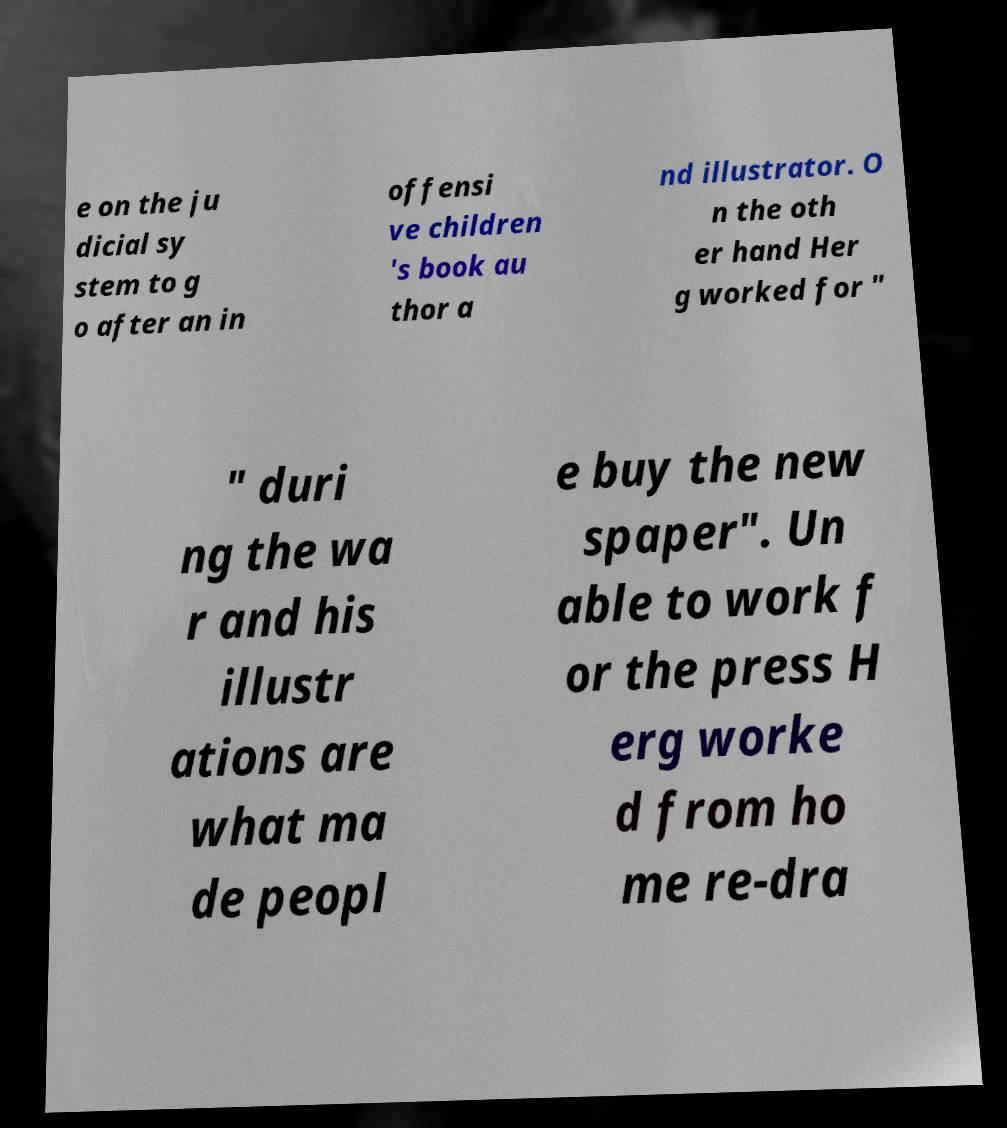I need the written content from this picture converted into text. Can you do that? e on the ju dicial sy stem to g o after an in offensi ve children 's book au thor a nd illustrator. O n the oth er hand Her g worked for " " duri ng the wa r and his illustr ations are what ma de peopl e buy the new spaper". Un able to work f or the press H erg worke d from ho me re-dra 